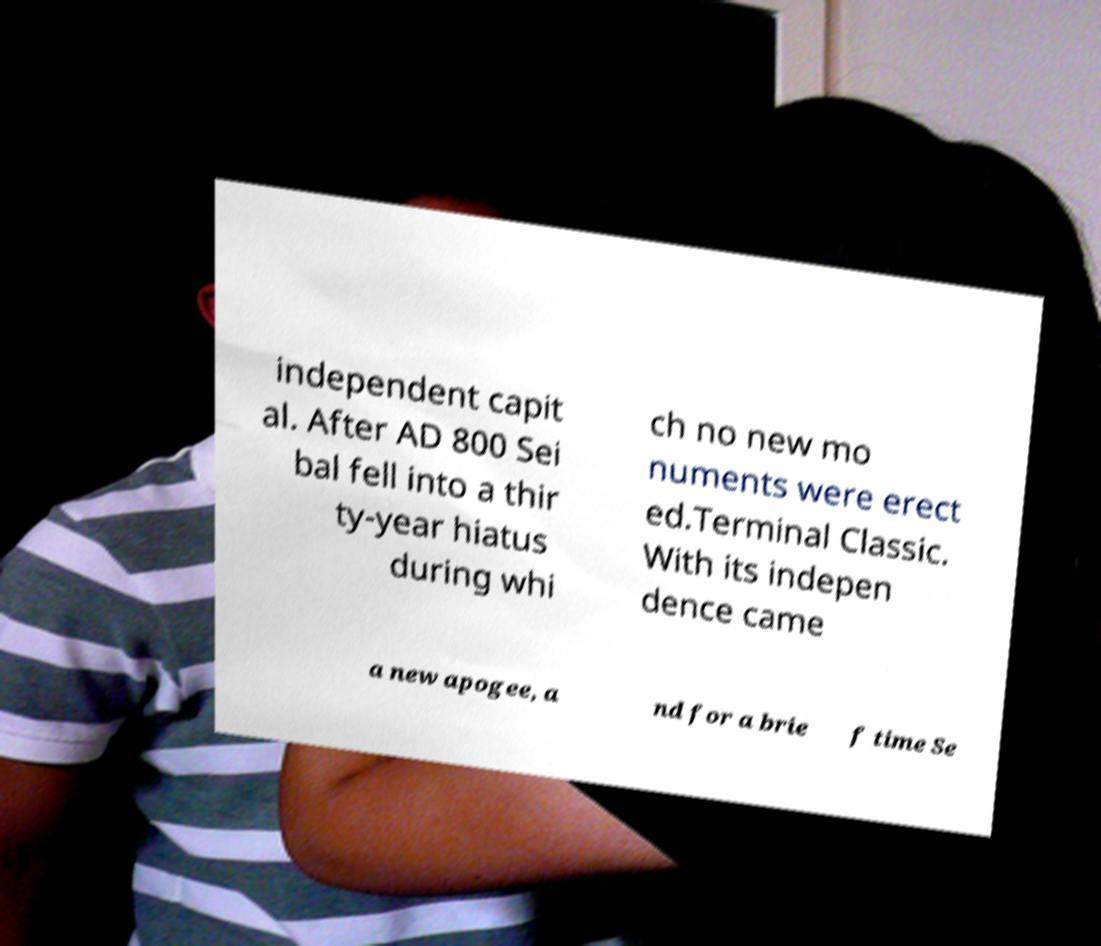Can you accurately transcribe the text from the provided image for me? independent capit al. After AD 800 Sei bal fell into a thir ty-year hiatus during whi ch no new mo numents were erect ed.Terminal Classic. With its indepen dence came a new apogee, a nd for a brie f time Se 